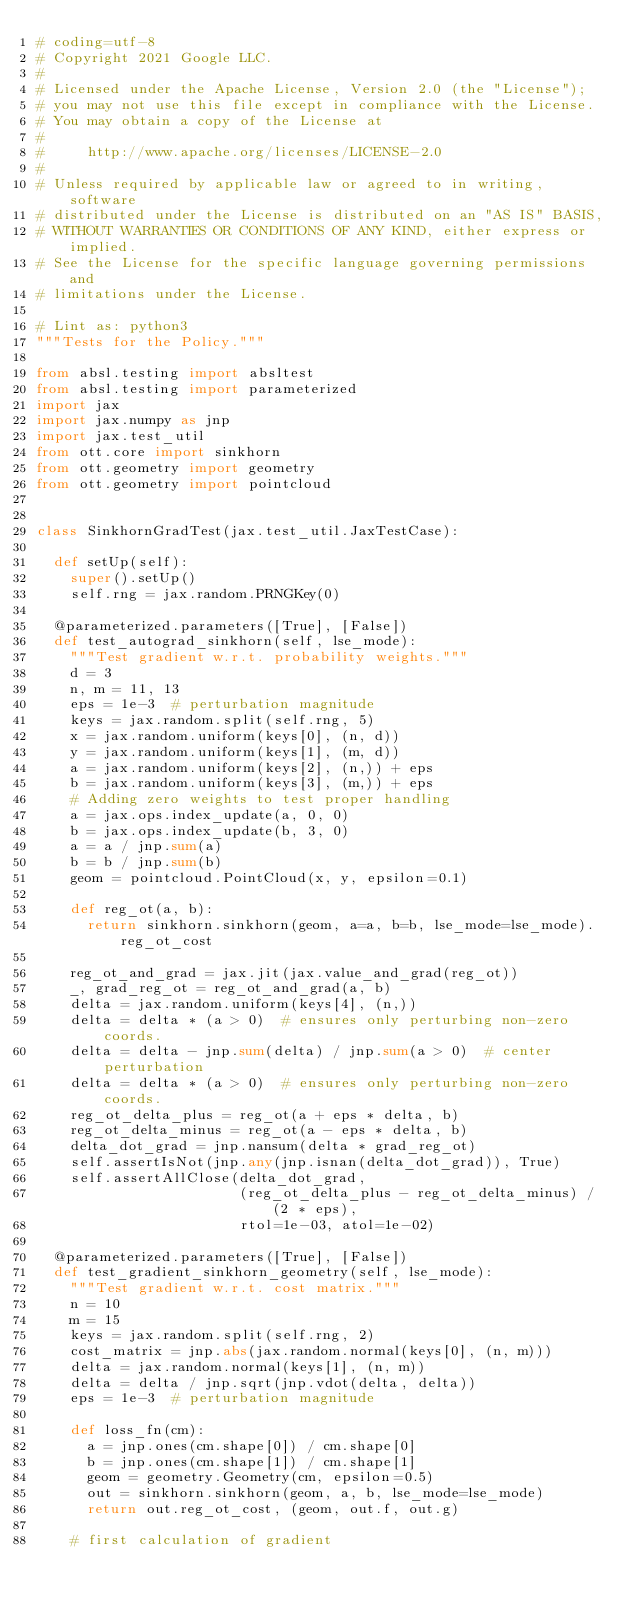<code> <loc_0><loc_0><loc_500><loc_500><_Python_># coding=utf-8
# Copyright 2021 Google LLC.
#
# Licensed under the Apache License, Version 2.0 (the "License");
# you may not use this file except in compliance with the License.
# You may obtain a copy of the License at
#
#     http://www.apache.org/licenses/LICENSE-2.0
#
# Unless required by applicable law or agreed to in writing, software
# distributed under the License is distributed on an "AS IS" BASIS,
# WITHOUT WARRANTIES OR CONDITIONS OF ANY KIND, either express or implied.
# See the License for the specific language governing permissions and
# limitations under the License.

# Lint as: python3
"""Tests for the Policy."""

from absl.testing import absltest
from absl.testing import parameterized
import jax
import jax.numpy as jnp
import jax.test_util
from ott.core import sinkhorn
from ott.geometry import geometry
from ott.geometry import pointcloud


class SinkhornGradTest(jax.test_util.JaxTestCase):

  def setUp(self):
    super().setUp()
    self.rng = jax.random.PRNGKey(0)

  @parameterized.parameters([True], [False])
  def test_autograd_sinkhorn(self, lse_mode):
    """Test gradient w.r.t. probability weights."""
    d = 3
    n, m = 11, 13
    eps = 1e-3  # perturbation magnitude
    keys = jax.random.split(self.rng, 5)
    x = jax.random.uniform(keys[0], (n, d))
    y = jax.random.uniform(keys[1], (m, d))
    a = jax.random.uniform(keys[2], (n,)) + eps
    b = jax.random.uniform(keys[3], (m,)) + eps
    # Adding zero weights to test proper handling
    a = jax.ops.index_update(a, 0, 0)
    b = jax.ops.index_update(b, 3, 0)
    a = a / jnp.sum(a)
    b = b / jnp.sum(b)
    geom = pointcloud.PointCloud(x, y, epsilon=0.1)

    def reg_ot(a, b):
      return sinkhorn.sinkhorn(geom, a=a, b=b, lse_mode=lse_mode).reg_ot_cost

    reg_ot_and_grad = jax.jit(jax.value_and_grad(reg_ot))
    _, grad_reg_ot = reg_ot_and_grad(a, b)
    delta = jax.random.uniform(keys[4], (n,))
    delta = delta * (a > 0)  # ensures only perturbing non-zero coords.
    delta = delta - jnp.sum(delta) / jnp.sum(a > 0)  # center perturbation
    delta = delta * (a > 0)  # ensures only perturbing non-zero coords.
    reg_ot_delta_plus = reg_ot(a + eps * delta, b)
    reg_ot_delta_minus = reg_ot(a - eps * delta, b)
    delta_dot_grad = jnp.nansum(delta * grad_reg_ot)
    self.assertIsNot(jnp.any(jnp.isnan(delta_dot_grad)), True)
    self.assertAllClose(delta_dot_grad,
                        (reg_ot_delta_plus - reg_ot_delta_minus) / (2 * eps),
                        rtol=1e-03, atol=1e-02)

  @parameterized.parameters([True], [False])
  def test_gradient_sinkhorn_geometry(self, lse_mode):
    """Test gradient w.r.t. cost matrix."""
    n = 10
    m = 15
    keys = jax.random.split(self.rng, 2)
    cost_matrix = jnp.abs(jax.random.normal(keys[0], (n, m)))
    delta = jax.random.normal(keys[1], (n, m))
    delta = delta / jnp.sqrt(jnp.vdot(delta, delta))
    eps = 1e-3  # perturbation magnitude

    def loss_fn(cm):
      a = jnp.ones(cm.shape[0]) / cm.shape[0]
      b = jnp.ones(cm.shape[1]) / cm.shape[1]
      geom = geometry.Geometry(cm, epsilon=0.5)
      out = sinkhorn.sinkhorn(geom, a, b, lse_mode=lse_mode)
      return out.reg_ot_cost, (geom, out.f, out.g)

    # first calculation of gradient</code> 